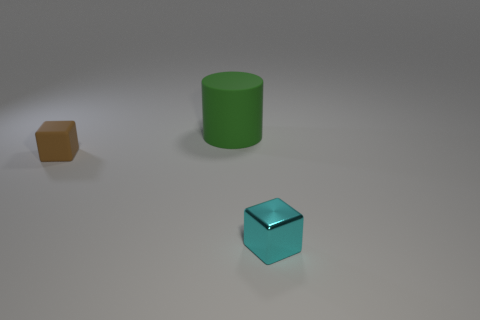Is there anything else that is the same size as the cylinder?
Your answer should be very brief. No. Is the number of cyan shiny cubes that are on the right side of the tiny cyan cube less than the number of tiny metal blocks that are in front of the green cylinder?
Provide a short and direct response. Yes. How many things are either small brown rubber blocks or tiny things that are on the right side of the rubber block?
Your answer should be very brief. 2. There is another thing that is the same size as the shiny object; what is it made of?
Offer a very short reply. Rubber. Does the brown thing have the same material as the tiny cyan block?
Your answer should be very brief. No. What color is the thing that is both behind the small cyan metallic thing and right of the brown object?
Your response must be concise. Green. The cyan thing that is the same size as the brown cube is what shape?
Keep it short and to the point. Cube. What number of other objects are the same color as the tiny rubber object?
Ensure brevity in your answer.  0. What number of other objects are there of the same material as the green cylinder?
Offer a terse response. 1. Is the size of the rubber cube the same as the matte thing to the right of the brown matte cube?
Provide a succinct answer. No. 